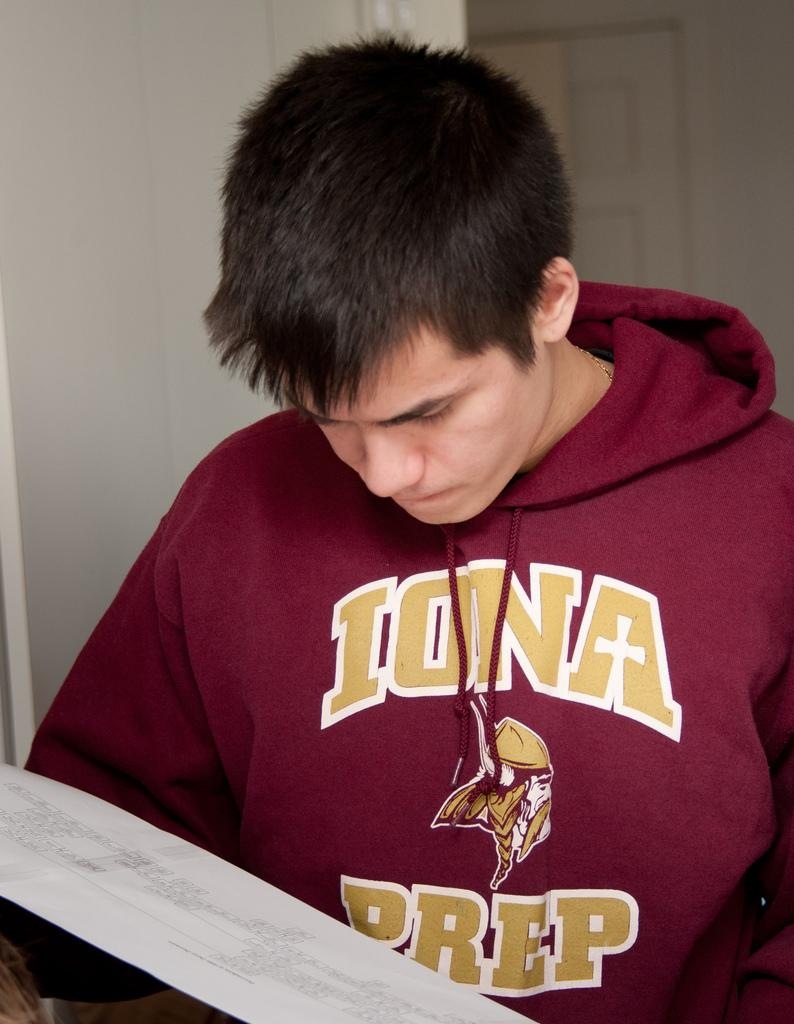<image>
Create a compact narrative representing the image presented. A man wearing a red Iona Prep sweatshirt 